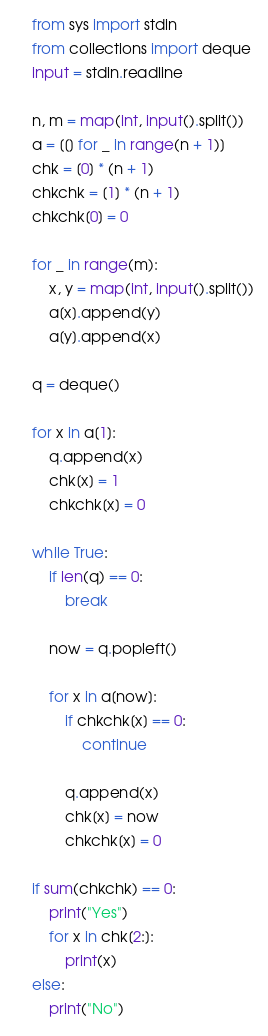<code> <loc_0><loc_0><loc_500><loc_500><_Python_>from sys import stdin
from collections import deque
input = stdin.readline

n, m = map(int, input().split())
a = [[] for _ in range(n + 1)]
chk = [0] * (n + 1)
chkchk = [1] * (n + 1)
chkchk[0] = 0

for _ in range(m):
    x, y = map(int, input().split())
    a[x].append(y)
    a[y].append(x)

q = deque()

for x in a[1]:
    q.append(x)
    chk[x] = 1
    chkchk[x] = 0

while True:
    if len(q) == 0:
        break

    now = q.popleft()

    for x in a[now]:
        if chkchk[x] == 0:
            continue

        q.append(x)
        chk[x] = now
        chkchk[x] = 0

if sum(chkchk) == 0:
    print("Yes")
    for x in chk[2:]:
        print(x)
else:
    print("No")</code> 